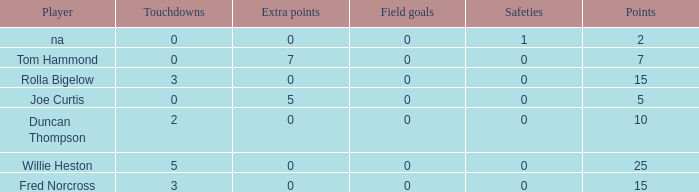How many Touchdowns have a Player of rolla bigelow, and an Extra points smaller than 0? None. 